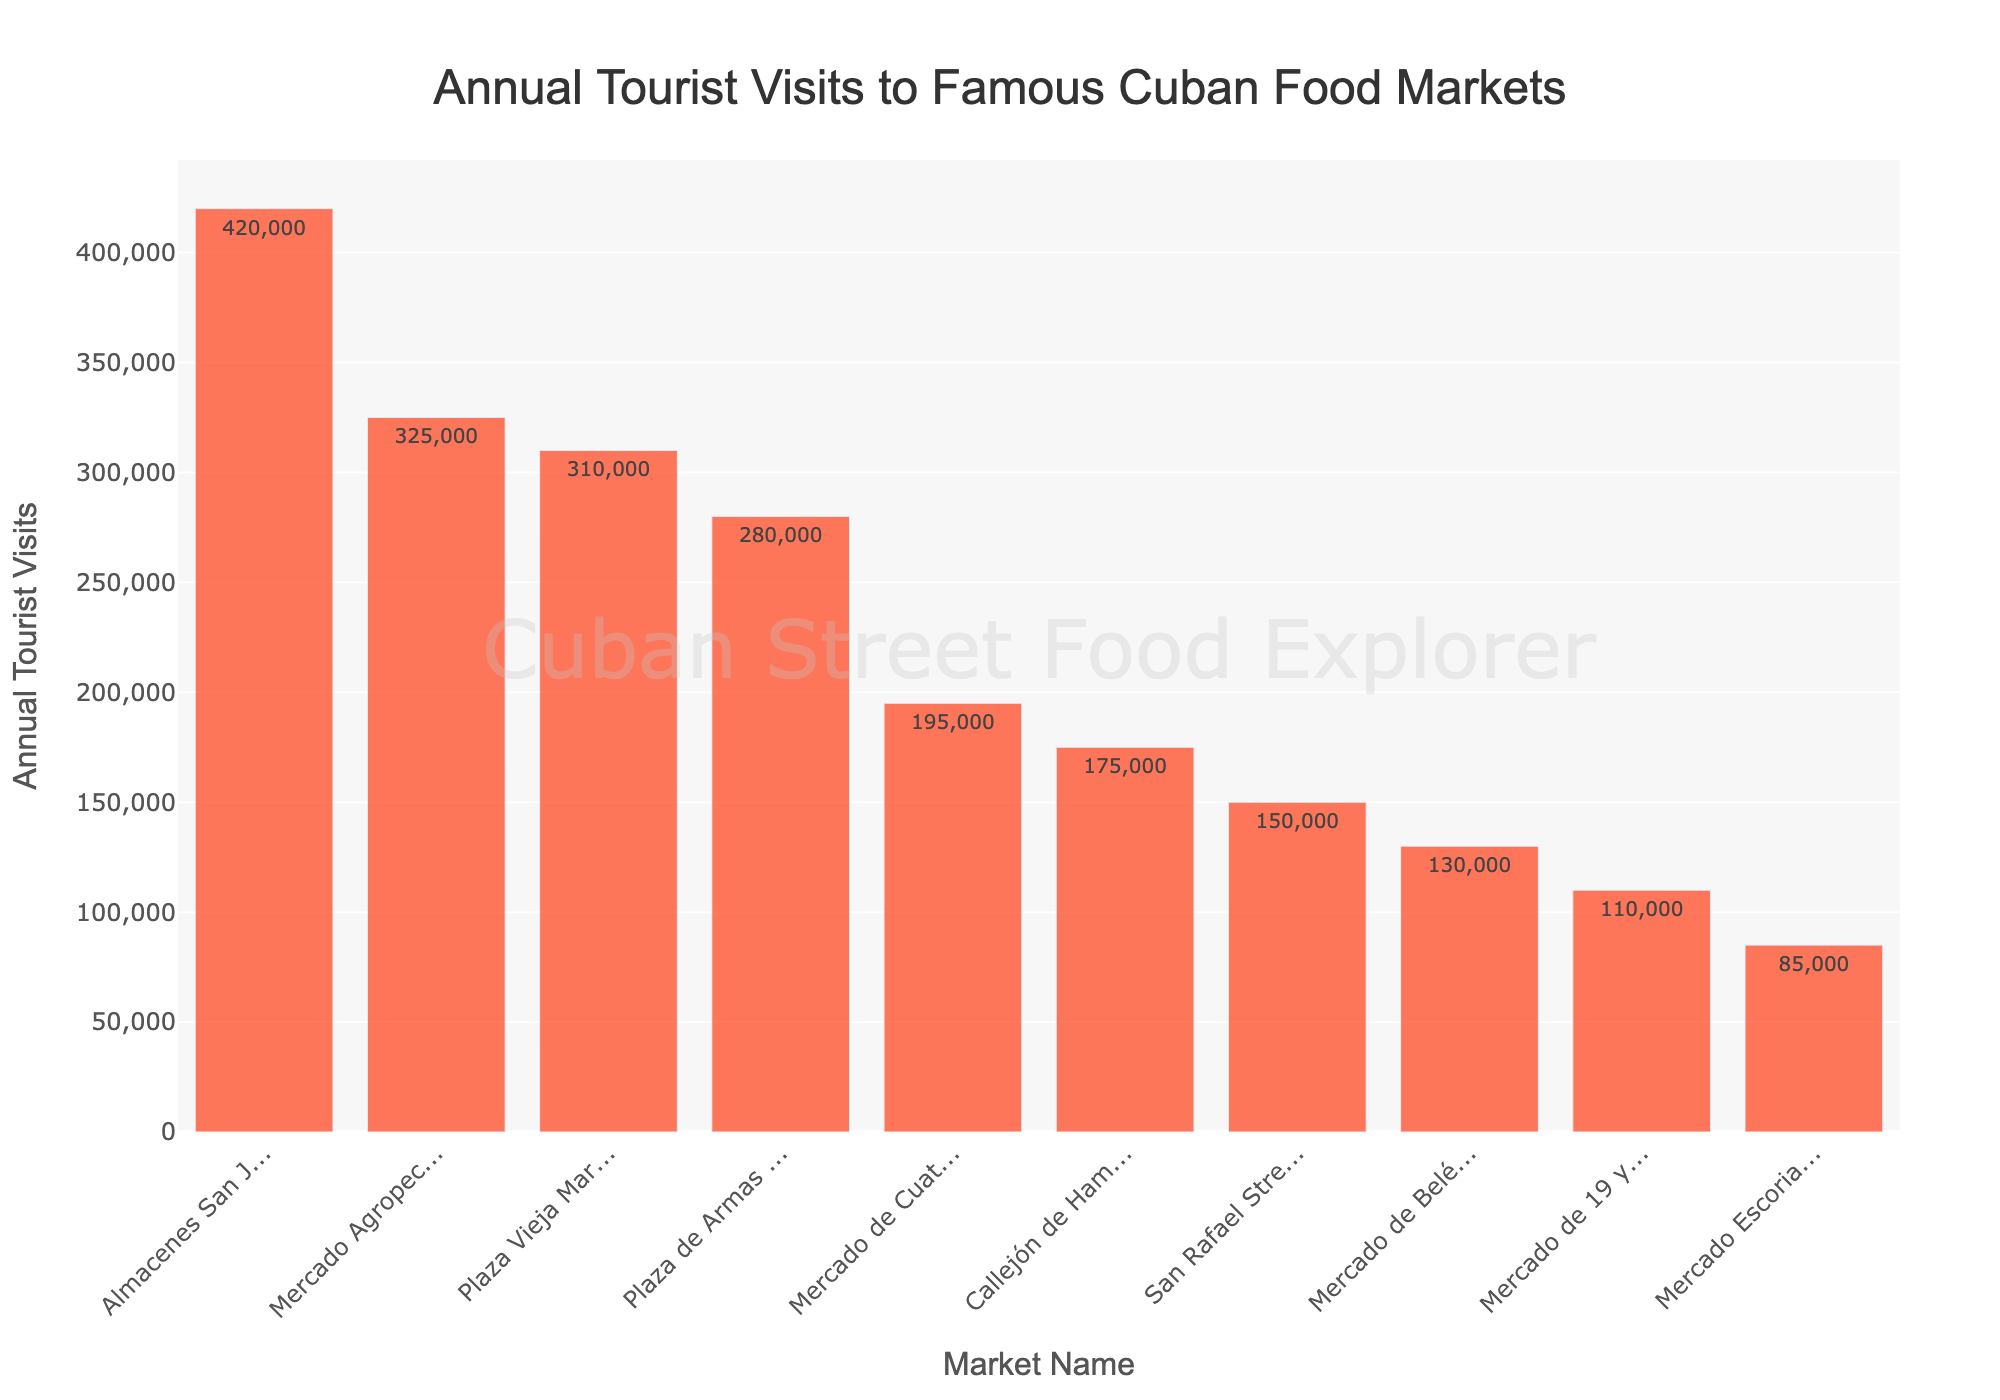What is the most visited market according to the bar chart? The bar chart shows "Almacenes San José Artisans' Market" has the highest bar, indicating the most annual tourist visits.
Answer: Almacenes San José Artisans' Market Which market receives the least number of annual tourist visits? The market with the shortest bar in the chart is "Mercado Escorial," indicating the least annual tourist visits.
Answer: Mercado Escorial How many more tourists visit "Almacenes San José Artisans' Market" compared to "Mercado Escorial"? According to the chart, "Almacenes San José Artisans' Market" has 420,000 visits, and "Mercado Escorial" has 85,000 visits. The difference is 420,000 - 85,000.
Answer: 335,000 What is the average number of annual tourist visits across all markets? To find the average, sum all annual visits and divide by the number of markets. Sum = 325,000 + 280,000 + 195,000 + 150,000 + 420,000 + 110,000 + 175,000 + 85,000 + 310,000 + 130,000 = 2,180,000. Average = 2,180,000 / 10.
Answer: 218,000 Do any markets have the same number of annual tourist visits? The bar chart indicates each market has a unique height, suggesting no two markets have the same number of annual visits.
Answer: No Which market has more tourists: "Plaza Vieja Market" or "Plaza de Armas Market"? By comparing the heights of the bars, "Plaza Vieja Market" has 310,000 visits, while "Plaza de Armas Market" has 280,000 visits.
Answer: Plaza Vieja Market What is the total number of tourists visiting the three least visited markets? The three least visited markets are "Mercado Escorial" (85,000), "Mercado de 19 y B" (110,000), and "Mercado de Belén" (130,000). Sum = 85,000 + 110,000 + 130,000.
Answer: 325,000 Which market ranks fourth in terms of annual tourist visits? The bar chart sorted by annual visits in descending order shows the fourth bar corresponds to "Plaza Vieja Market."
Answer: Plaza Vieja Market Does the "San Rafael Street Market" attract more visitors than the "Callejón de Hamel Market"? Comparing their bars, "San Rafael Street Market" has 150,000 visits and "Callejón de Hamel Market" has 175,000 visits.
Answer: No How many markets receive more than 300,000 annual tourist visits? The bar chart shows four markets with bars extending beyond the 300,000 mark: "Almacenes San José Artisans' Market," "Mercado Agropecuario Egido," "Plaza Vieja Market," and "Plaza de Armas Market."
Answer: Four 